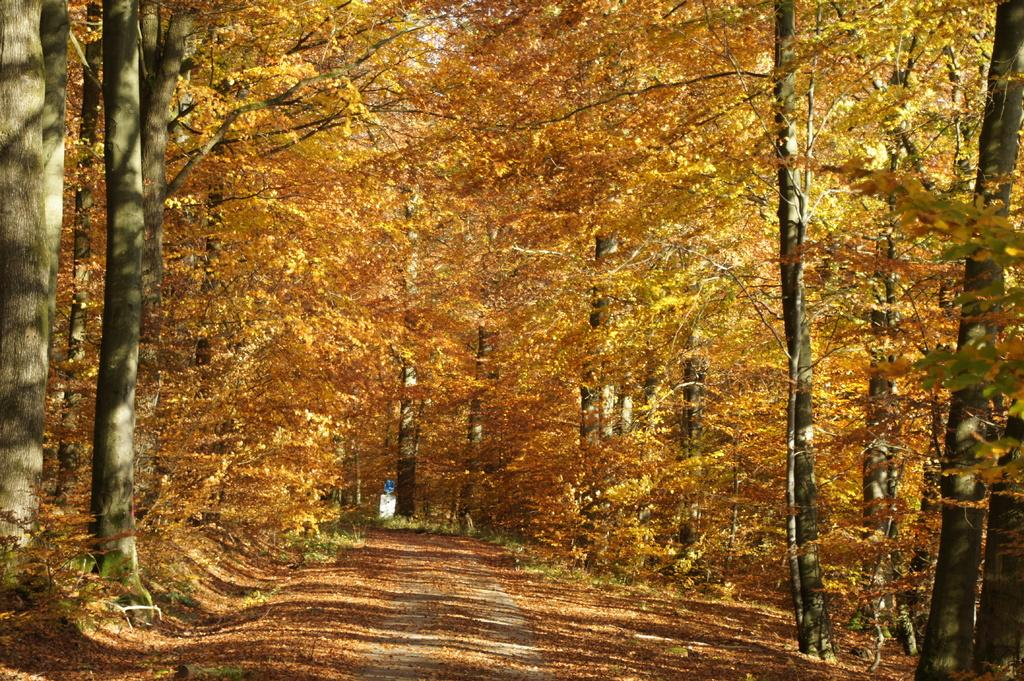What is the main feature of the image? There is a road in the image. What can be seen alongside the road? Trees are present on the sides of the road. What is the size of the silver object in the image? There is no silver object present in the image. 